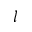<formula> <loc_0><loc_0><loc_500><loc_500>l</formula> 